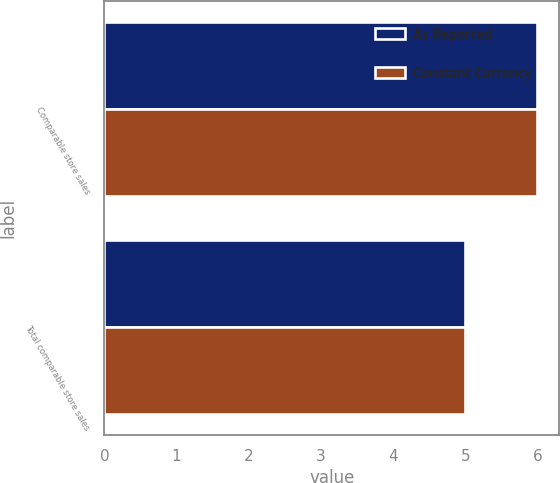Convert chart to OTSL. <chart><loc_0><loc_0><loc_500><loc_500><stacked_bar_chart><ecel><fcel>Comparable store sales<fcel>Total comparable store sales<nl><fcel>As Reported<fcel>6<fcel>5<nl><fcel>Constant Currency<fcel>6<fcel>5<nl></chart> 